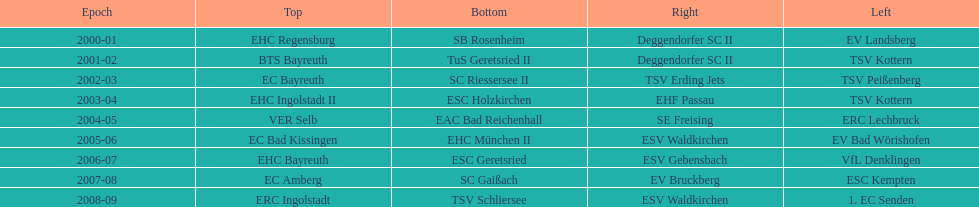Which name appears more often, kottern or bayreuth? Bayreuth. 